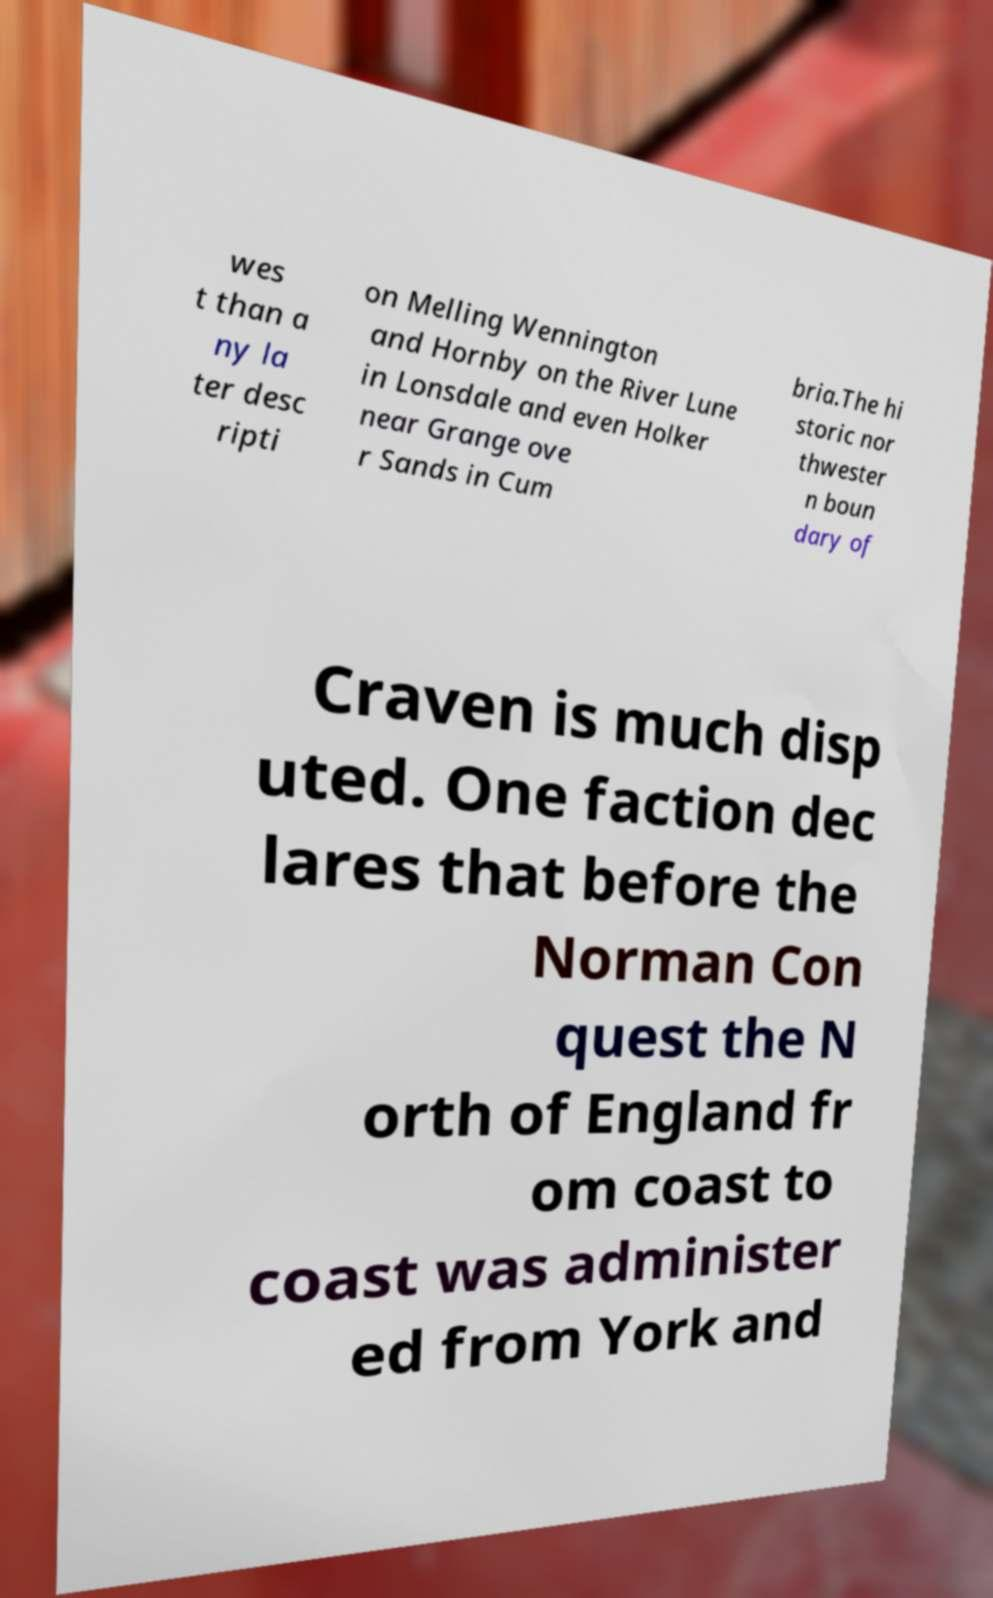What messages or text are displayed in this image? I need them in a readable, typed format. wes t than a ny la ter desc ripti on Melling Wennington and Hornby on the River Lune in Lonsdale and even Holker near Grange ove r Sands in Cum bria.The hi storic nor thwester n boun dary of Craven is much disp uted. One faction dec lares that before the Norman Con quest the N orth of England fr om coast to coast was administer ed from York and 